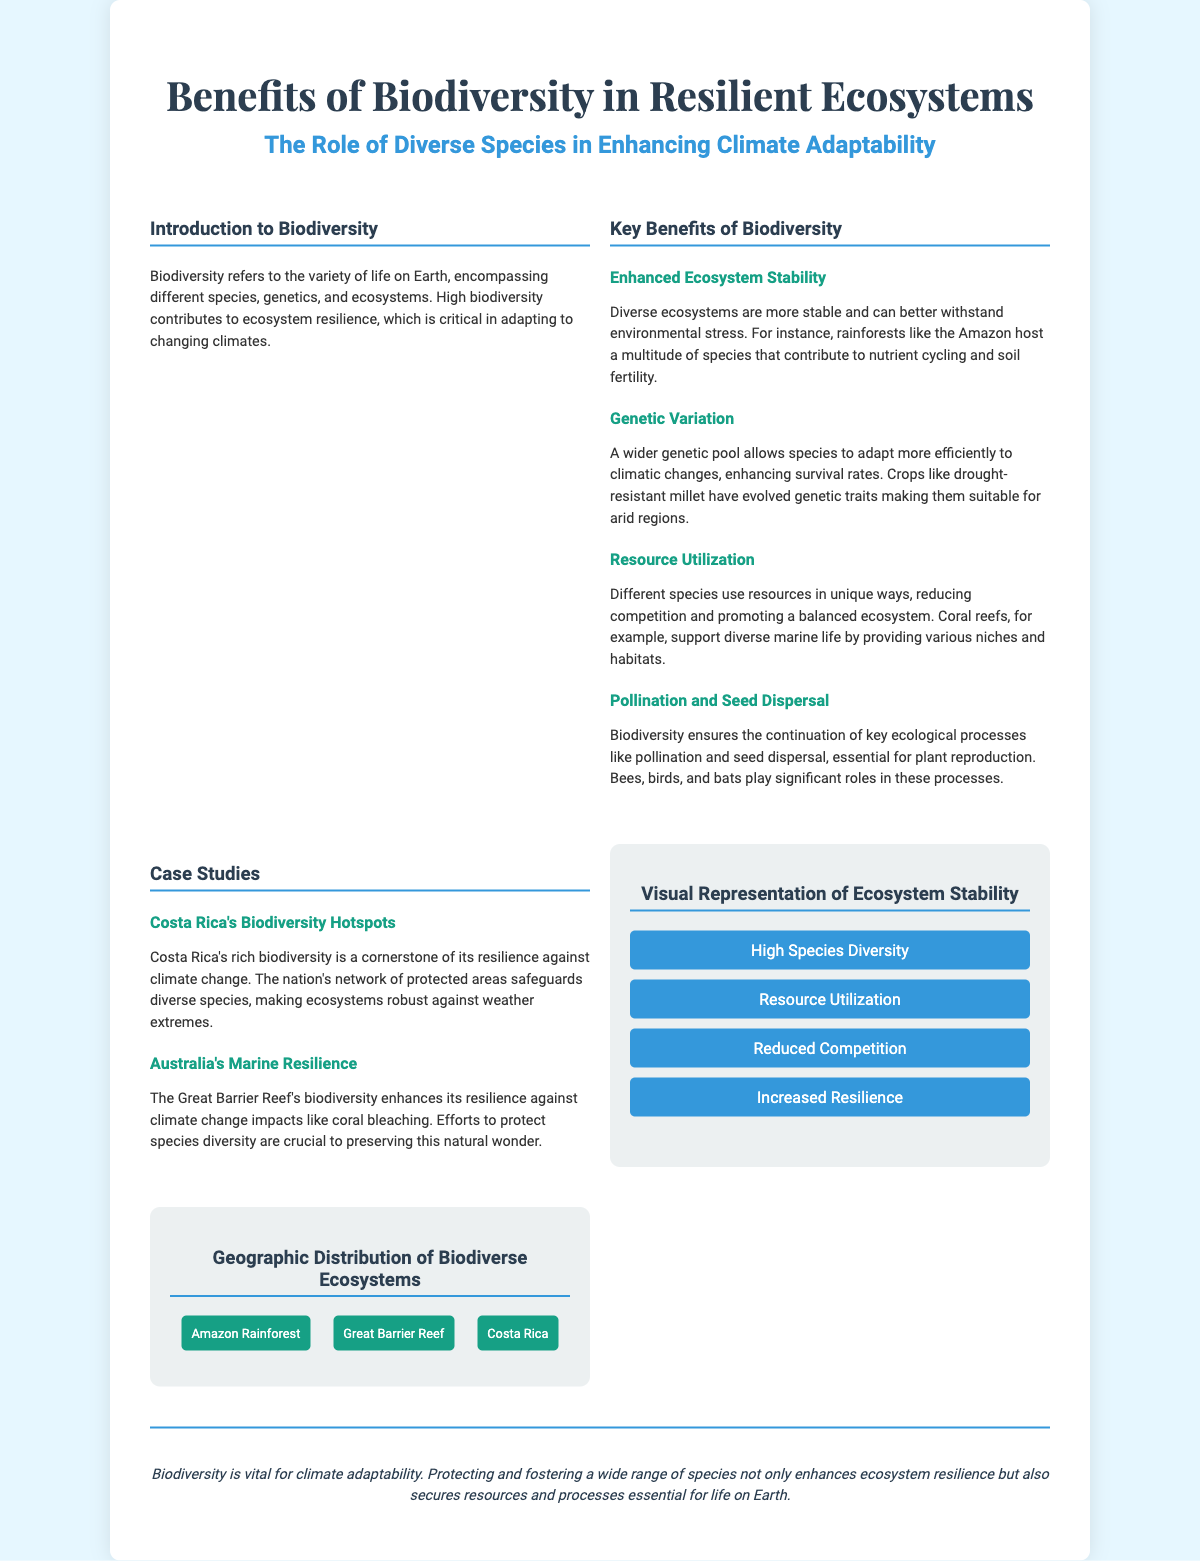What is the title of the poster? The title can be found at the top of the document, summarizing the main topic.
Answer: Benefits of Biodiversity in Resilient Ecosystems What does biodiversity refer to? The definition is provided in the introduction section of the poster.
Answer: The variety of life on Earth What are the four key benefits of biodiversity listed? The document specifies different benefits under the Key Benefits of Biodiversity section.
Answer: Enhanced Ecosystem Stability, Genetic Variation, Resource Utilization, Pollination and Seed Dispersal Which specific case study is mentioned for marine resilience? The document gives specific examples under the Case Studies section.
Answer: Australia’s Marine Resilience What role do bees, birds, and bats play in ecosystems? Their function is explained in the Pollination and Seed Dispersal subsection.
Answer: Key ecological processes Why is Costa Rica's biodiversity important? The significance is described in the context of climate change resilience in the document.
Answer: A cornerstone of its resilience against climate change Which infographic representation is shown? The infographic section lists the elements related to ecosystem stability.
Answer: High Species Diversity, Resource Utilization, Reduced Competition, Increased Resilience What geographic area is listed for biodiversity? The geographic distribution of biodiverse ecosystems section shows specific locations.
Answer: Amazon Rainforest What is stated as vital for climate adaptability? The conclusion summarizes the overall importance of biodiversity.
Answer: Biodiversity 